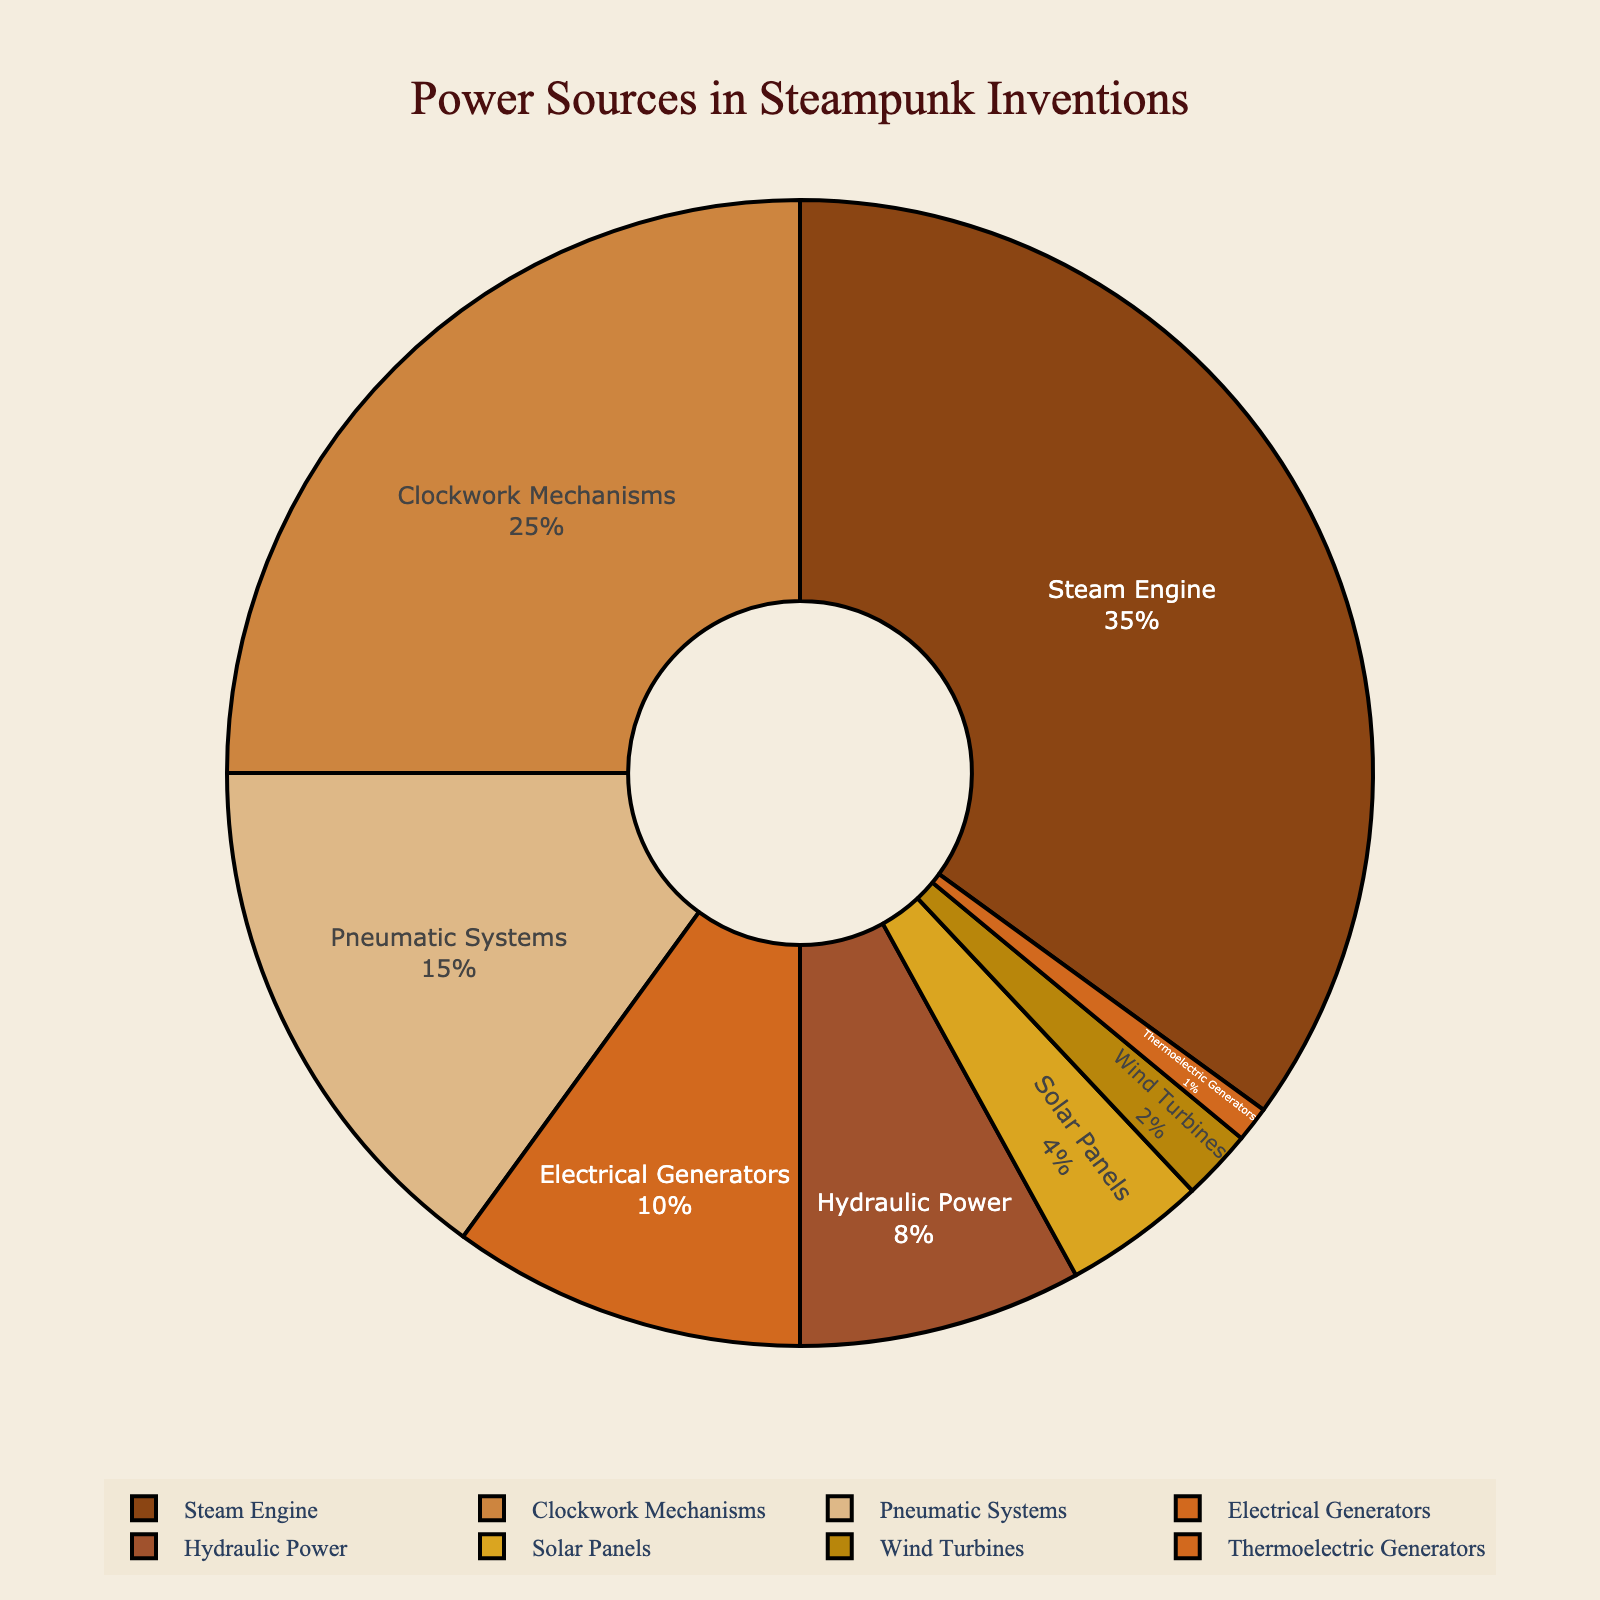Which power source is the most used in steampunk inventions? The figure shows a pie chart with percentages for different power sources. The largest segment represents Steam Engine at 35%, indicating it is the most used power source.
Answer: Steam Engine What is the combined percentage of power sources that are used less than 10% each? The power sources that are used less than 10% each are Hydraulic Power (8%), Solar Panels (4%), Wind Turbines (2%), and Thermoelectric Generators (1%). Adding these percentages together: 8 + 4 + 2 + 1 = 15%.
Answer: 15% Which power source has the smallest share in steampunk inventions? The pie chart shows the smallest segment, which represents Thermoelectric Generators with a percentage of 1%, indicating it has the smallest share.
Answer: Thermoelectric Generators What is the difference in percentage between Steam Engine and Clockwork Mechanisms? According to the pie chart, Steam Engine is 35% and Clockwork Mechanisms is 25%. The difference is calculated by subtracting the lesser percentage from the greater: 35 - 25 = 10%.
Answer: 10% How many power sources have a share greater than 15%? The pie chart indicates the percentages for each power source. Steam Engine (35%) and Clockwork Mechanisms (25%) are the only sources over 15%, so the count is 2.
Answer: 2 What percentage of steampunk inventions use either Steam Engine or Electrical Generators as power sources? The pie chart shows Steam Engine at 35% and Electrical Generators at 10%. Adding these percentages together: 35 + 10 = 45%.
Answer: 45% Among Pneumatic Systems and Hydraulic Power, which is more prevalent? According to the chart, Pneumatic Systems have 15% whereas Hydraulic Power has 8%. Therefore, Pneumatic Systems have a greater share.
Answer: Pneumatic Systems If you combine the percentages for Pneumatic Systems and Hydraulic Power, what proportion of the total does it make up? The pie chart shows Pneumatic Systems at 15% and Hydraulic Power at 8%. Adding these together gives: 15% + 8% = 23%.
Answer: 23% Which power sources collectively represent more than half (over 50%) of the usage in steampunk inventions? From the pie chart, Steam Engine (35%) and Clockwork Mechanisms (25%) together constitute 60%, which is more than half of the total.
Answer: Steam Engine and Clockwork Mechanisms 